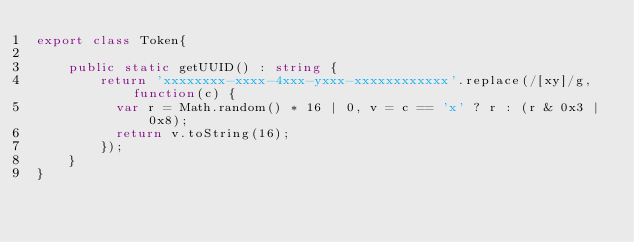Convert code to text. <code><loc_0><loc_0><loc_500><loc_500><_TypeScript_>export class Token{

    public static getUUID() : string {
        return 'xxxxxxxx-xxxx-4xxx-yxxx-xxxxxxxxxxxx'.replace(/[xy]/g, function(c) {
          var r = Math.random() * 16 | 0, v = c == 'x' ? r : (r & 0x3 | 0x8);
          return v.toString(16);
        });
    }
}</code> 